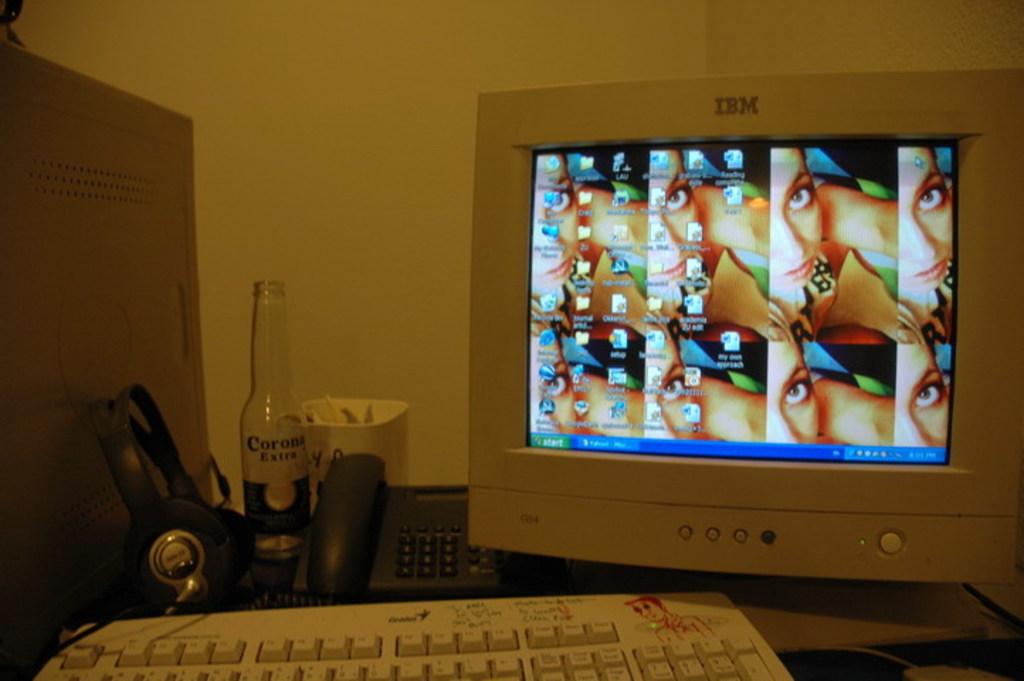What company makes that monitor?
Provide a short and direct response. Ibm. What brand of beer is on this desk?
Provide a succinct answer. Corona. 